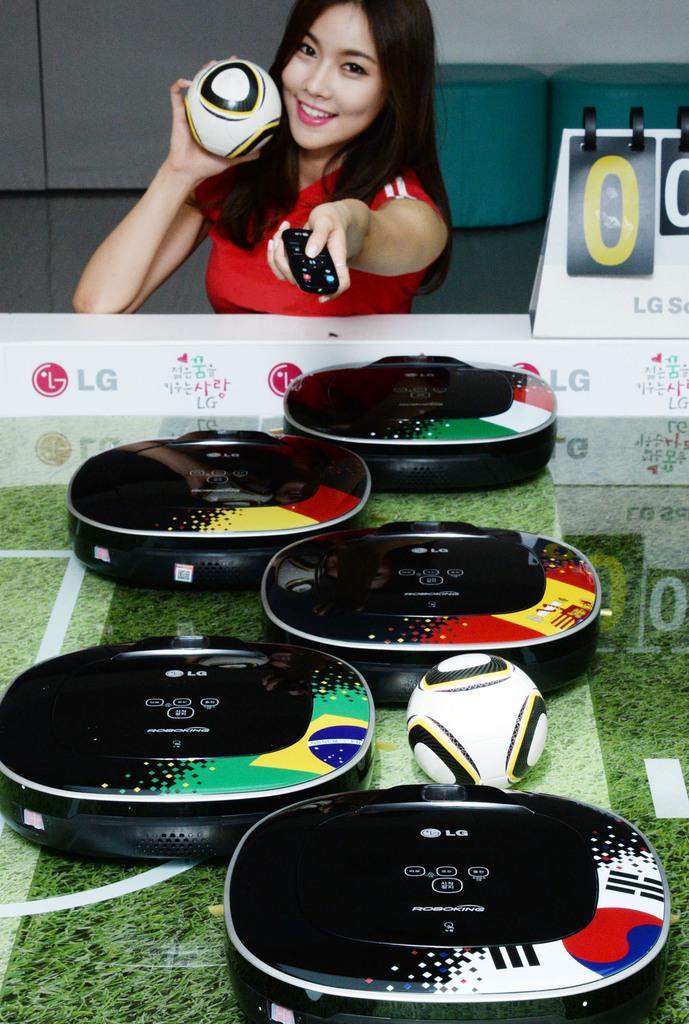Could you give a brief overview of what you see in this image? In this image in the front there are objects which are black in colour which is on the green colour surface. In the background there is a woman holding a remote and a ball in her hand and smiling and there is a banner with some text written on it and on the right side there is a paper with numbers written on it. 